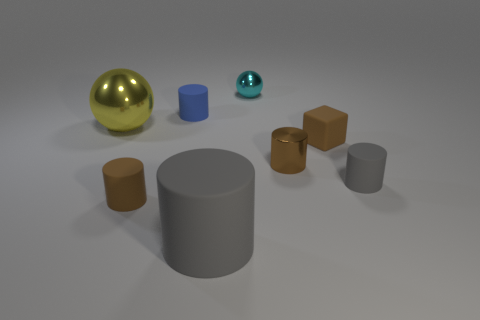Is the number of tiny gray matte objects that are to the left of the tiny sphere greater than the number of yellow metallic balls?
Make the answer very short. No. Is the material of the brown block the same as the tiny blue cylinder?
Your response must be concise. Yes. What number of other things are there of the same shape as the small blue thing?
Keep it short and to the point. 4. Is there any other thing that has the same material as the tiny brown block?
Offer a very short reply. Yes. There is a ball left of the cylinder left of the matte cylinder behind the yellow metal ball; what is its color?
Offer a very short reply. Yellow. Does the small brown matte thing to the left of the shiny cylinder have the same shape as the yellow shiny thing?
Provide a succinct answer. No. What number of small brown metal cubes are there?
Make the answer very short. 0. What number of metal cylinders have the same size as the brown block?
Give a very brief answer. 1. What is the blue cylinder made of?
Offer a very short reply. Rubber. Does the metallic cylinder have the same color as the sphere that is behind the big shiny ball?
Keep it short and to the point. No. 